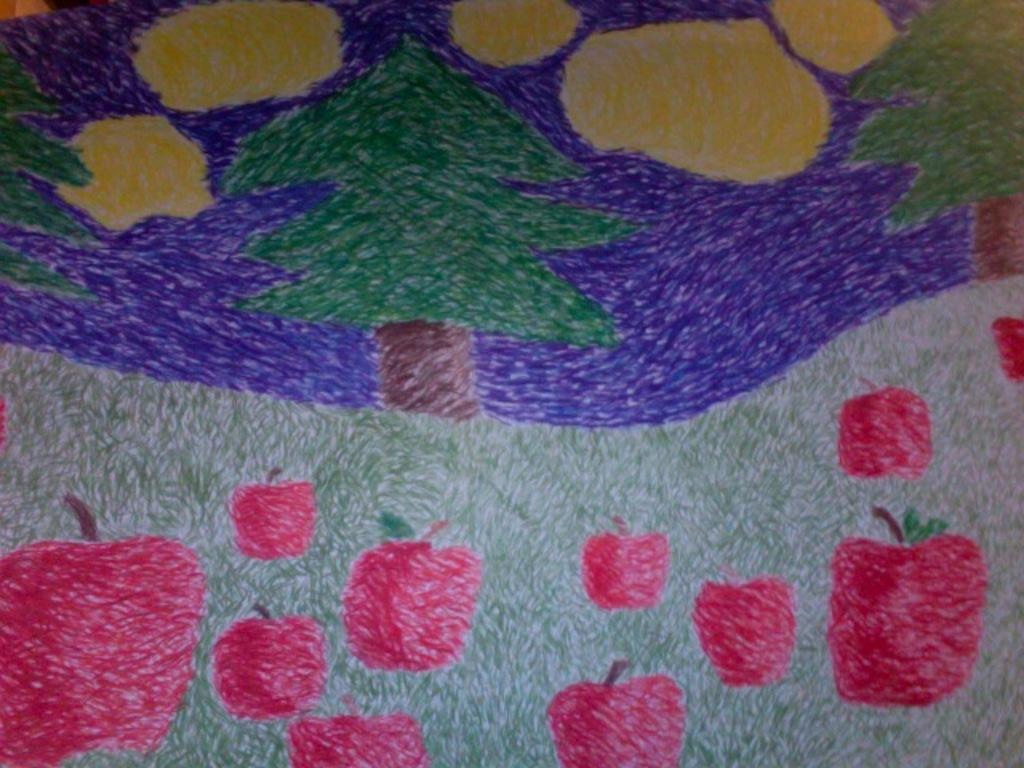What is the main subject of the image? There is a drawing in the image. What type of natural elements can be seen in the image? There are trees in the image. What is located on the grass in the image? There are apples on the grass in the image. What is the value of the duck in the image? There is no duck present in the image, so it is not possible to determine its value. 